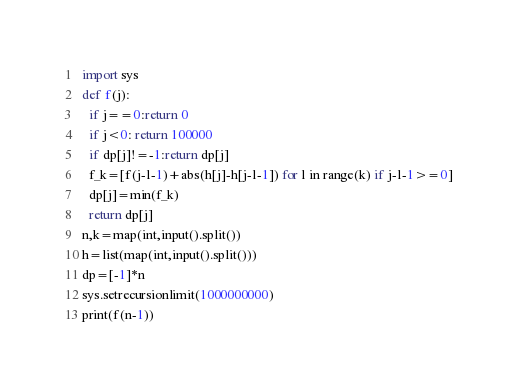Convert code to text. <code><loc_0><loc_0><loc_500><loc_500><_Python_>import sys
def f(j):
  if j==0:return 0
  if j<0: return 100000
  if dp[j]!=-1:return dp[j]
  f_k=[f(j-l-1)+abs(h[j]-h[j-l-1]) for l in range(k) if j-l-1>=0]
  dp[j]=min(f_k)
  return dp[j]
n,k=map(int,input().split())
h=list(map(int,input().split()))
dp=[-1]*n
sys.setrecursionlimit(1000000000)
print(f(n-1))</code> 